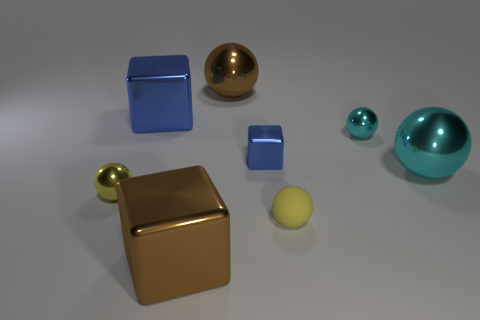What is the shape of the thing that is behind the yellow shiny ball and in front of the small blue cube?
Keep it short and to the point. Sphere. Does the yellow metallic thing have the same size as the brown metallic cube?
Ensure brevity in your answer.  No. There is a small yellow metallic object; what number of yellow matte spheres are left of it?
Ensure brevity in your answer.  0. Is the number of large blue objects left of the large blue cube the same as the number of brown metallic things that are left of the tiny blue metal thing?
Offer a terse response. No. There is a blue shiny object that is left of the brown shiny ball; is its shape the same as the small blue object?
Give a very brief answer. Yes. Do the yellow matte thing and the yellow thing left of the yellow rubber object have the same size?
Provide a succinct answer. Yes. How many other things are there of the same color as the tiny rubber sphere?
Your answer should be very brief. 1. There is a large blue metallic cube; are there any small rubber objects left of it?
Provide a succinct answer. No. What number of things are either small yellow balls or blue things on the left side of the big brown metallic ball?
Make the answer very short. 3. Is there a yellow object that is to the left of the tiny object to the right of the tiny yellow matte ball?
Your answer should be very brief. Yes. 